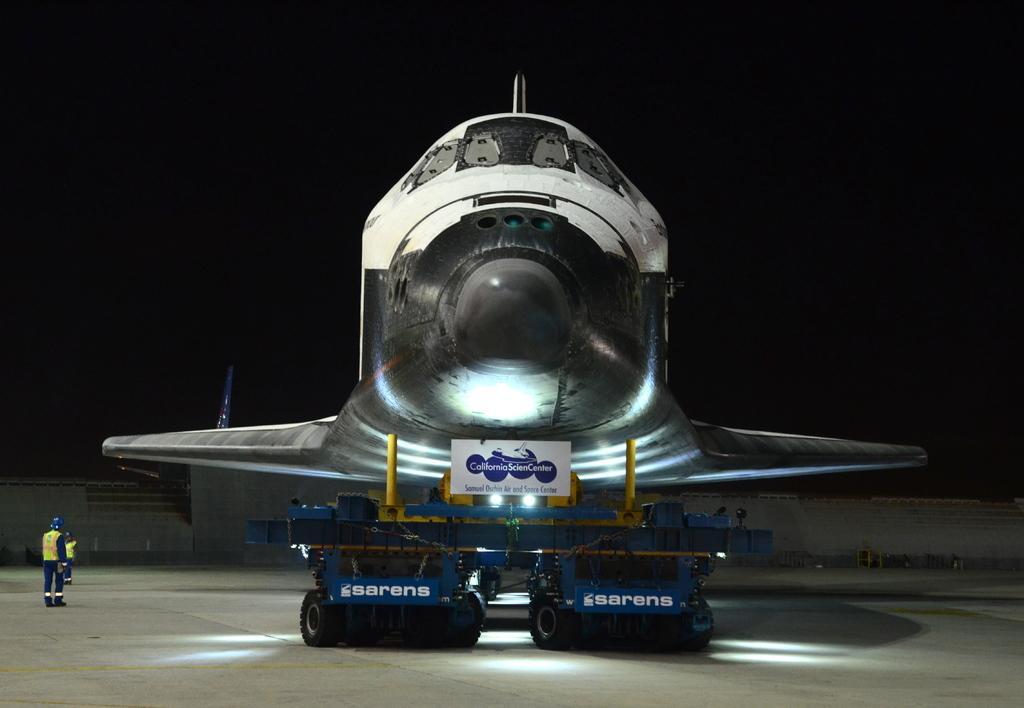Can you describe this image briefly? In the picture we can see an aircraft which is in construction and kept on the stand with some wheels to it and besides it, we can see some persons are standing wearing a jacket and helmets and in the background we can see a wall. 